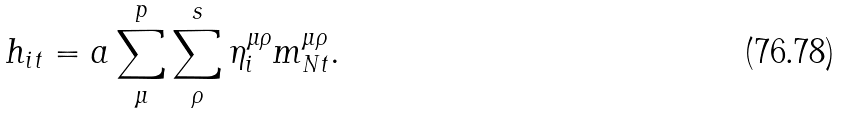<formula> <loc_0><loc_0><loc_500><loc_500>h _ { i t } = a \sum _ { \mu } ^ { p } \sum _ { \rho } ^ { s } \eta ^ { \mu \rho } _ { i } m ^ { \mu \rho } _ { N t } .</formula> 